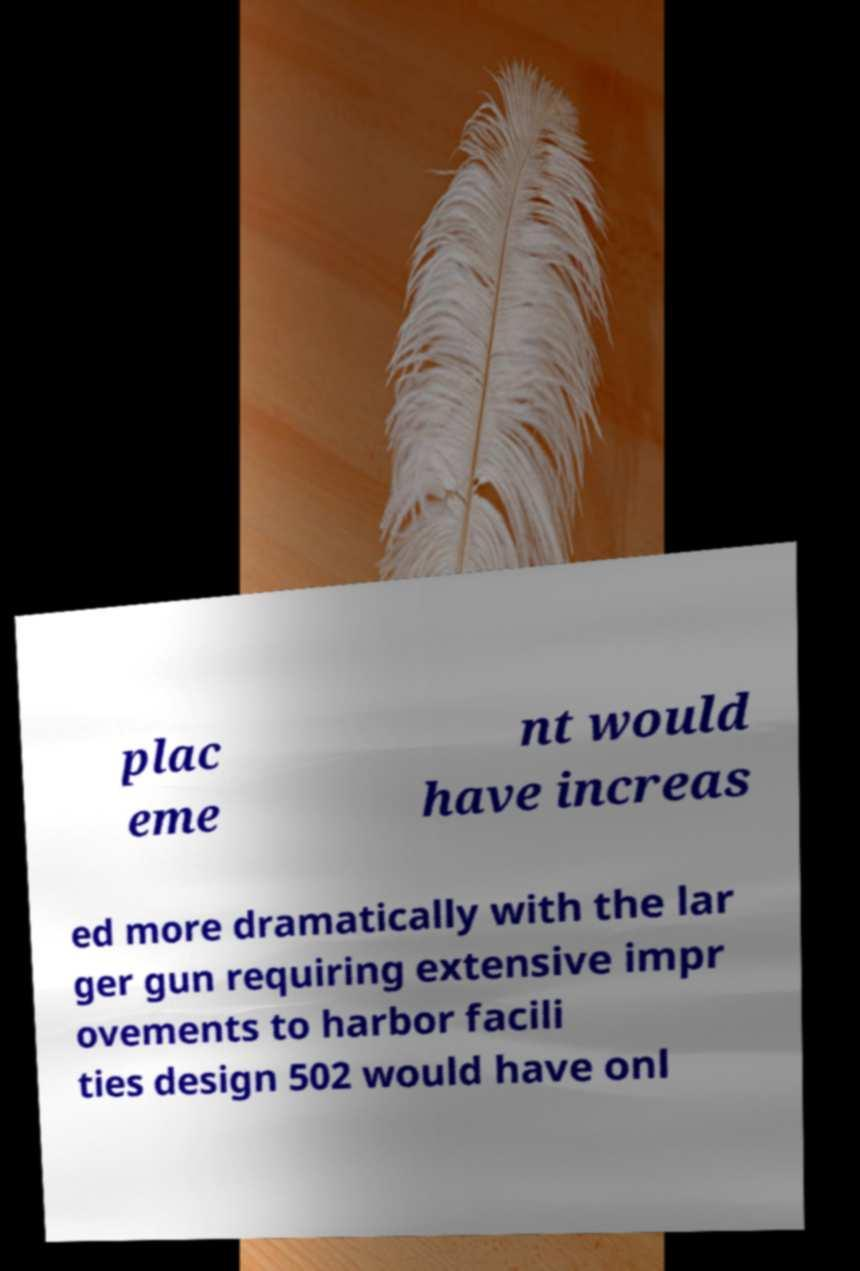Could you extract and type out the text from this image? plac eme nt would have increas ed more dramatically with the lar ger gun requiring extensive impr ovements to harbor facili ties design 502 would have onl 